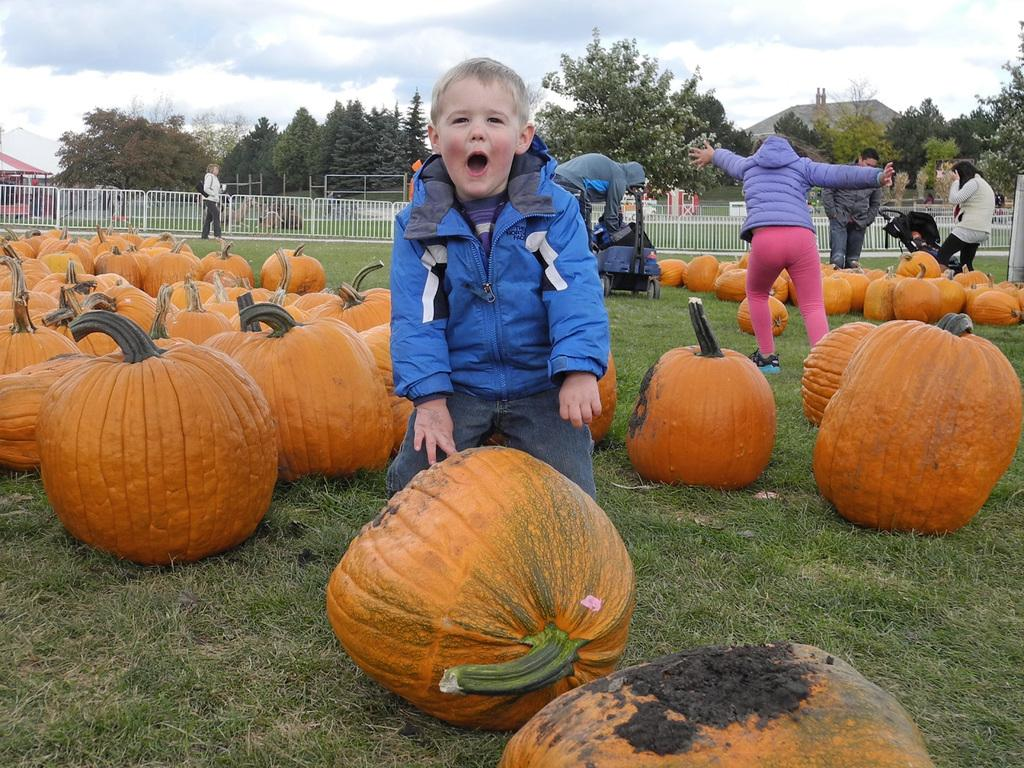Where was the image taken? The image was taken in a ground. What can be seen in the image besides the ground? There are pumpkins, people, fencing, houses, trees, and a cloudy sky visible in the image. How many types of objects can be seen in the background of the image? There are three types of objects in the background: fencing, houses, and trees. What type of mint is being distributed on the page in the image? There is no mint or page present in the image; it features pumpkins, people, and other outdoor elements. 